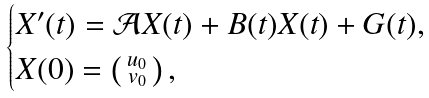<formula> <loc_0><loc_0><loc_500><loc_500>\begin{cases} X ^ { \prime } ( t ) = \mathcal { A } X ( t ) + B ( t ) X ( t ) + G ( t ) , \\ X ( 0 ) = \left ( \begin{smallmatrix} u _ { 0 } \\ v _ { 0 } \end{smallmatrix} \right ) , \end{cases}</formula> 